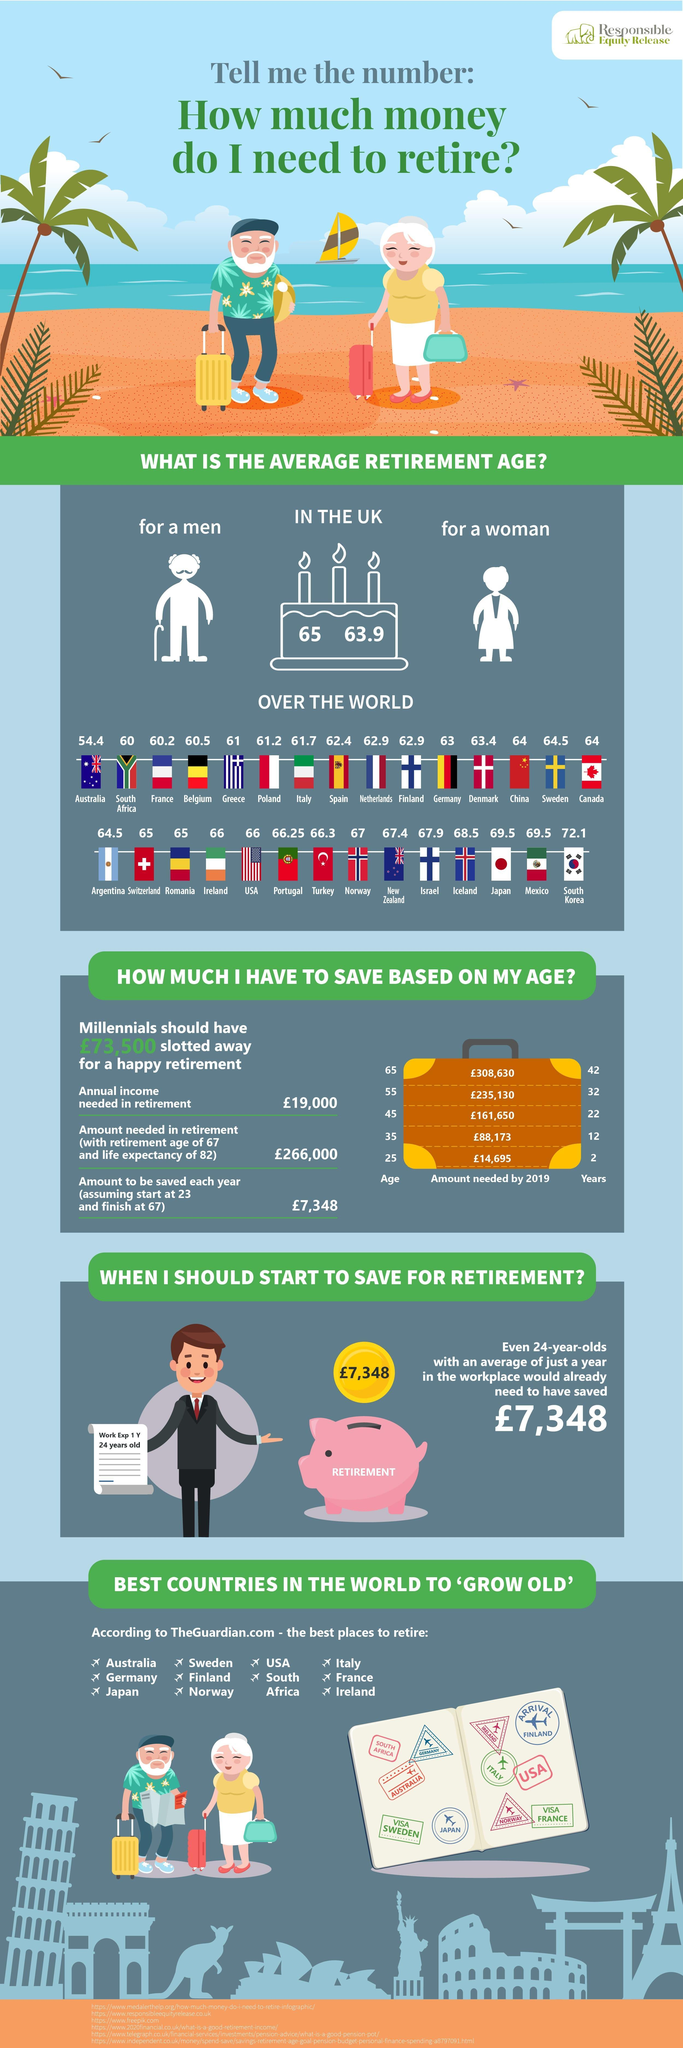What is the average retirement age of people in Greece?
Answer the question with a short phrase. 61 What is the average retirement age for a woman in UK? 63.9 What is the average retirement age of people in France? 60.2 What is the average retirement age of people in Norway? 67 What is the average retirement age of people in Italy? 61.7 What is the average retirement age of people in USA? 66 What is the average retirement age of people in Poland? 61.2 What is the average retirement age of people in Romania? 65 What is the average retirement age of people in Germany? 63 What is the average retirement age of people in Japan? 69.5 